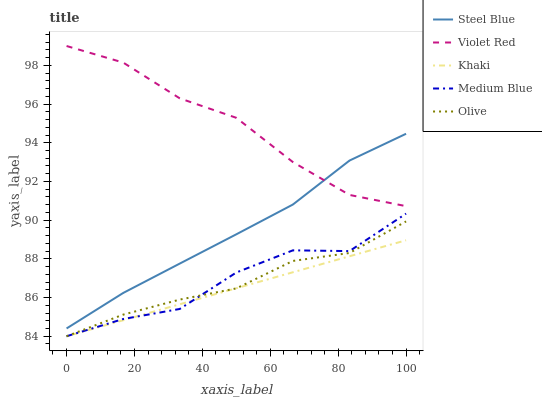Does Violet Red have the minimum area under the curve?
Answer yes or no. No. Does Khaki have the maximum area under the curve?
Answer yes or no. No. Is Violet Red the smoothest?
Answer yes or no. No. Is Violet Red the roughest?
Answer yes or no. No. Does Violet Red have the lowest value?
Answer yes or no. No. Does Khaki have the highest value?
Answer yes or no. No. Is Khaki less than Steel Blue?
Answer yes or no. Yes. Is Violet Red greater than Khaki?
Answer yes or no. Yes. Does Khaki intersect Steel Blue?
Answer yes or no. No. 